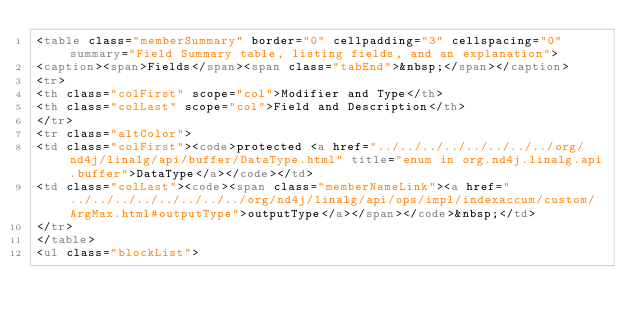Convert code to text. <code><loc_0><loc_0><loc_500><loc_500><_HTML_><table class="memberSummary" border="0" cellpadding="3" cellspacing="0" summary="Field Summary table, listing fields, and an explanation">
<caption><span>Fields</span><span class="tabEnd">&nbsp;</span></caption>
<tr>
<th class="colFirst" scope="col">Modifier and Type</th>
<th class="colLast" scope="col">Field and Description</th>
</tr>
<tr class="altColor">
<td class="colFirst"><code>protected <a href="../../../../../../../../org/nd4j/linalg/api/buffer/DataType.html" title="enum in org.nd4j.linalg.api.buffer">DataType</a></code></td>
<td class="colLast"><code><span class="memberNameLink"><a href="../../../../../../../../org/nd4j/linalg/api/ops/impl/indexaccum/custom/ArgMax.html#outputType">outputType</a></span></code>&nbsp;</td>
</tr>
</table>
<ul class="blockList"></code> 